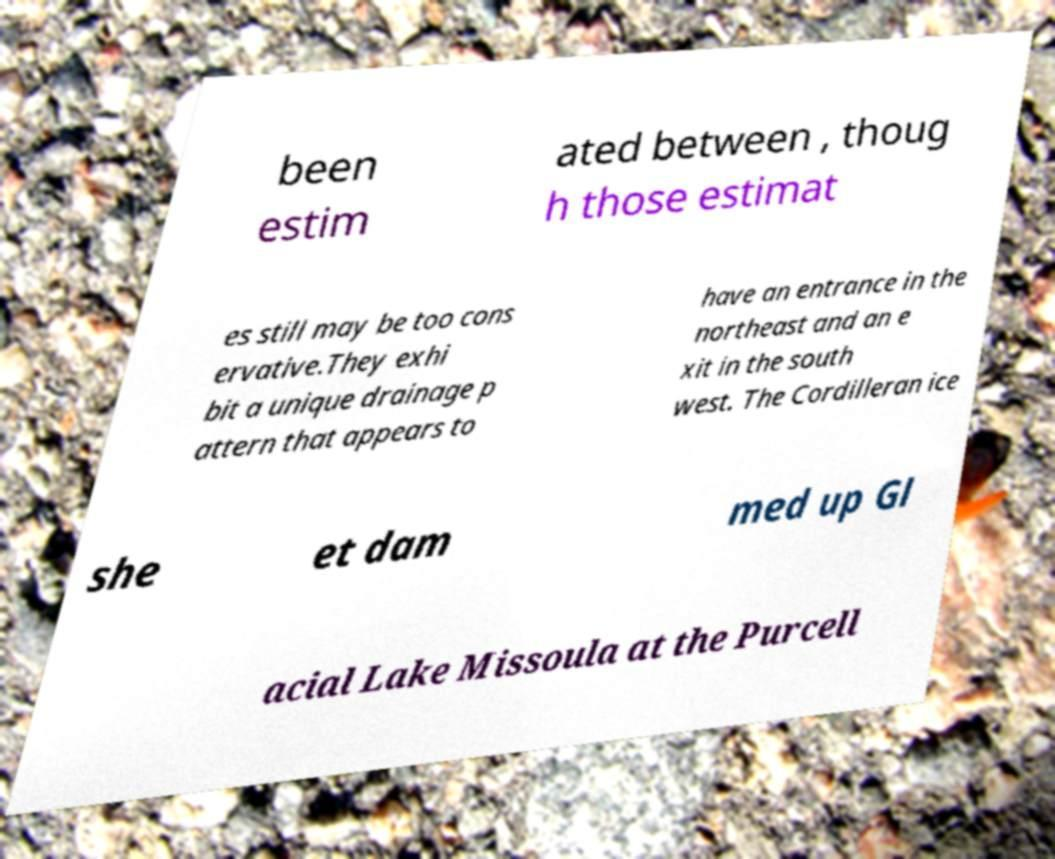Please read and relay the text visible in this image. What does it say? been estim ated between , thoug h those estimat es still may be too cons ervative.They exhi bit a unique drainage p attern that appears to have an entrance in the northeast and an e xit in the south west. The Cordilleran ice she et dam med up Gl acial Lake Missoula at the Purcell 